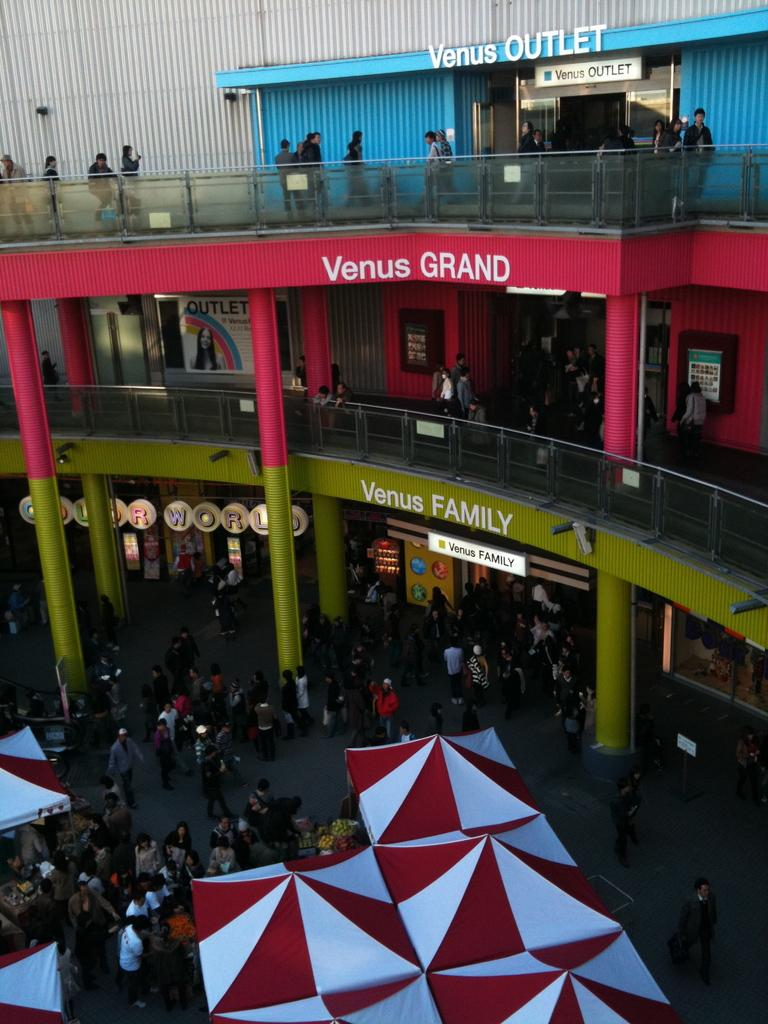What are the people in the image doing? The people in the image are on the floor. What type of tents can be seen in the image? There are white and red color tents in the image. How many floors are visible in the image? There are two floors visible in the image. What architectural feature can be seen in the image? There are pillars in the image. What type of glass is being used to draw on the floor in the image? There is no glass or drawing activity present in the image. How many legs can be seen on the people in the image? The image does not show the legs of the people; it only shows them from the waist up. 